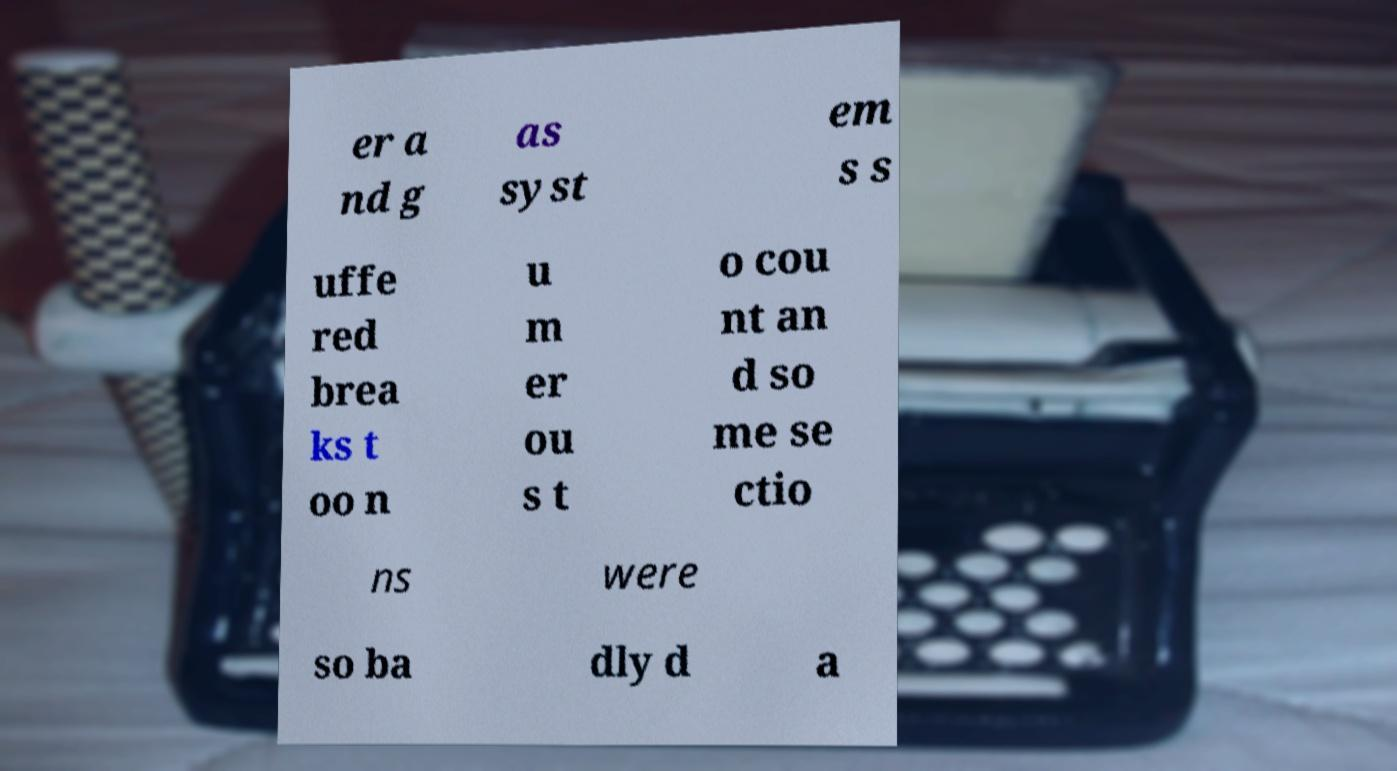Could you assist in decoding the text presented in this image and type it out clearly? er a nd g as syst em s s uffe red brea ks t oo n u m er ou s t o cou nt an d so me se ctio ns were so ba dly d a 